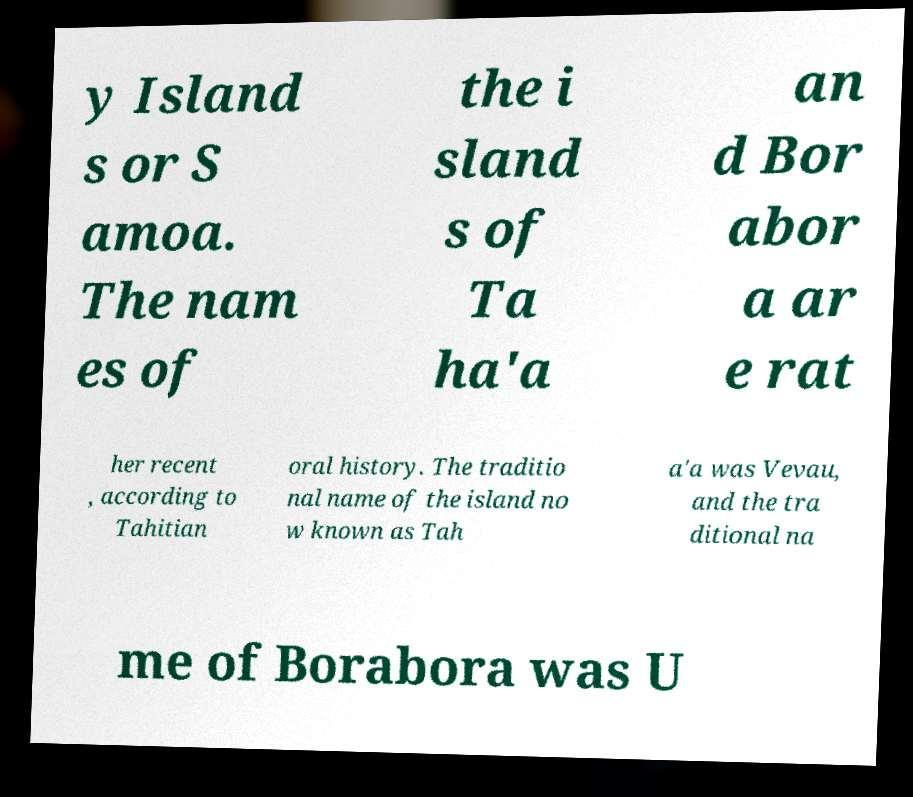Can you accurately transcribe the text from the provided image for me? y Island s or S amoa. The nam es of the i sland s of Ta ha'a an d Bor abor a ar e rat her recent , according to Tahitian oral history. The traditio nal name of the island no w known as Tah a'a was Vevau, and the tra ditional na me of Borabora was U 